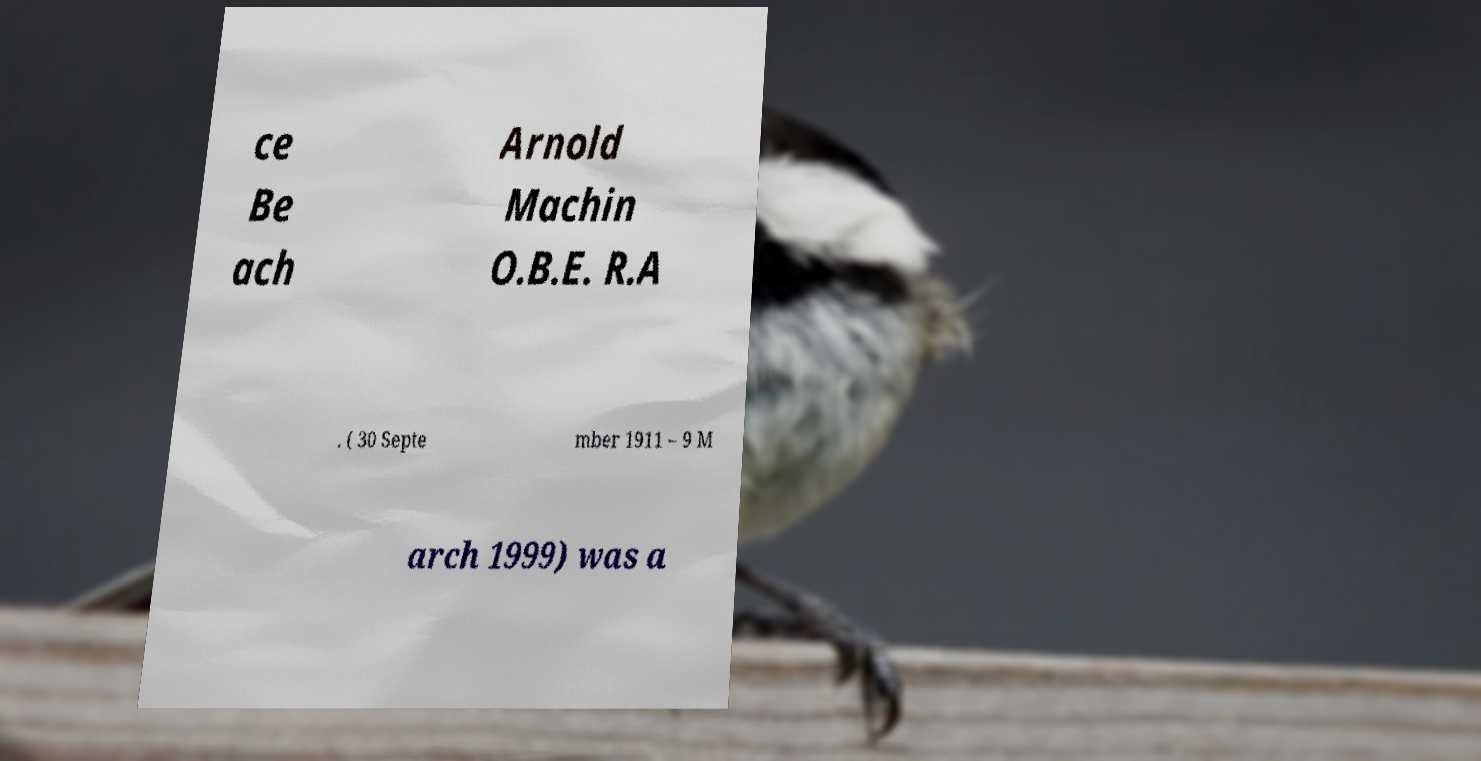What messages or text are displayed in this image? I need them in a readable, typed format. ce Be ach Arnold Machin O.B.E. R.A . ( 30 Septe mber 1911 – 9 M arch 1999) was a 